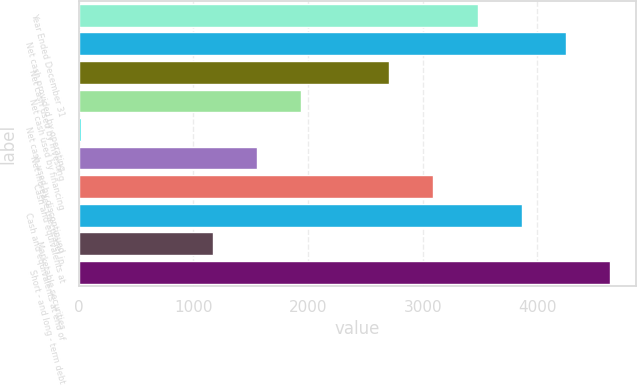Convert chart to OTSL. <chart><loc_0><loc_0><loc_500><loc_500><bar_chart><fcel>Year Ended December 31<fcel>Net cash provided by operating<fcel>Net cash used by investing<fcel>Net cash used by financing<fcel>Net cash used by discontinued<fcel>Net increase (decrease) in<fcel>Cash and equivalents at<fcel>Cash and equivalents at end of<fcel>Marketable securities<fcel>Short - and long - term debt<nl><fcel>3479.1<fcel>4248.9<fcel>2709.3<fcel>1939.5<fcel>15<fcel>1554.6<fcel>3094.2<fcel>3864<fcel>1169.7<fcel>4633.8<nl></chart> 